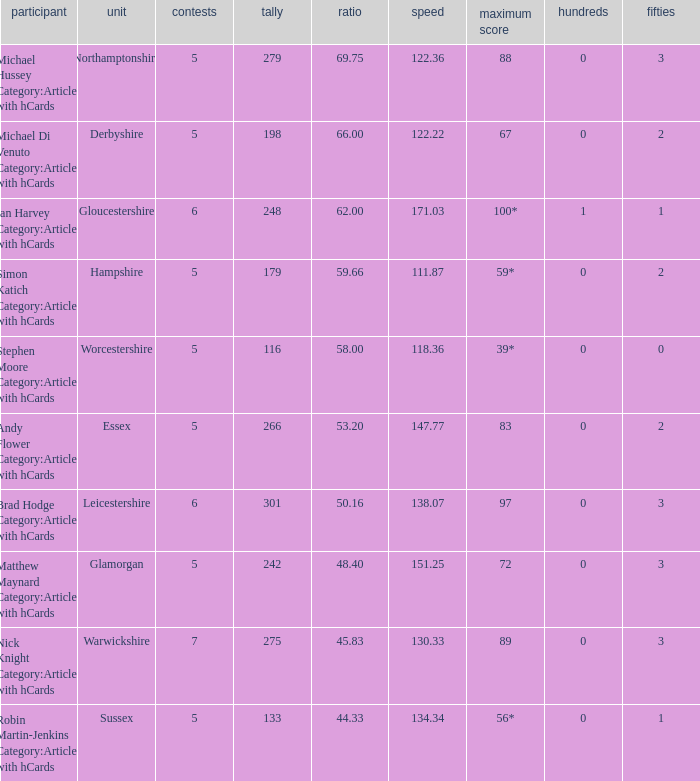What is the smallest amount of matches? 5.0. 